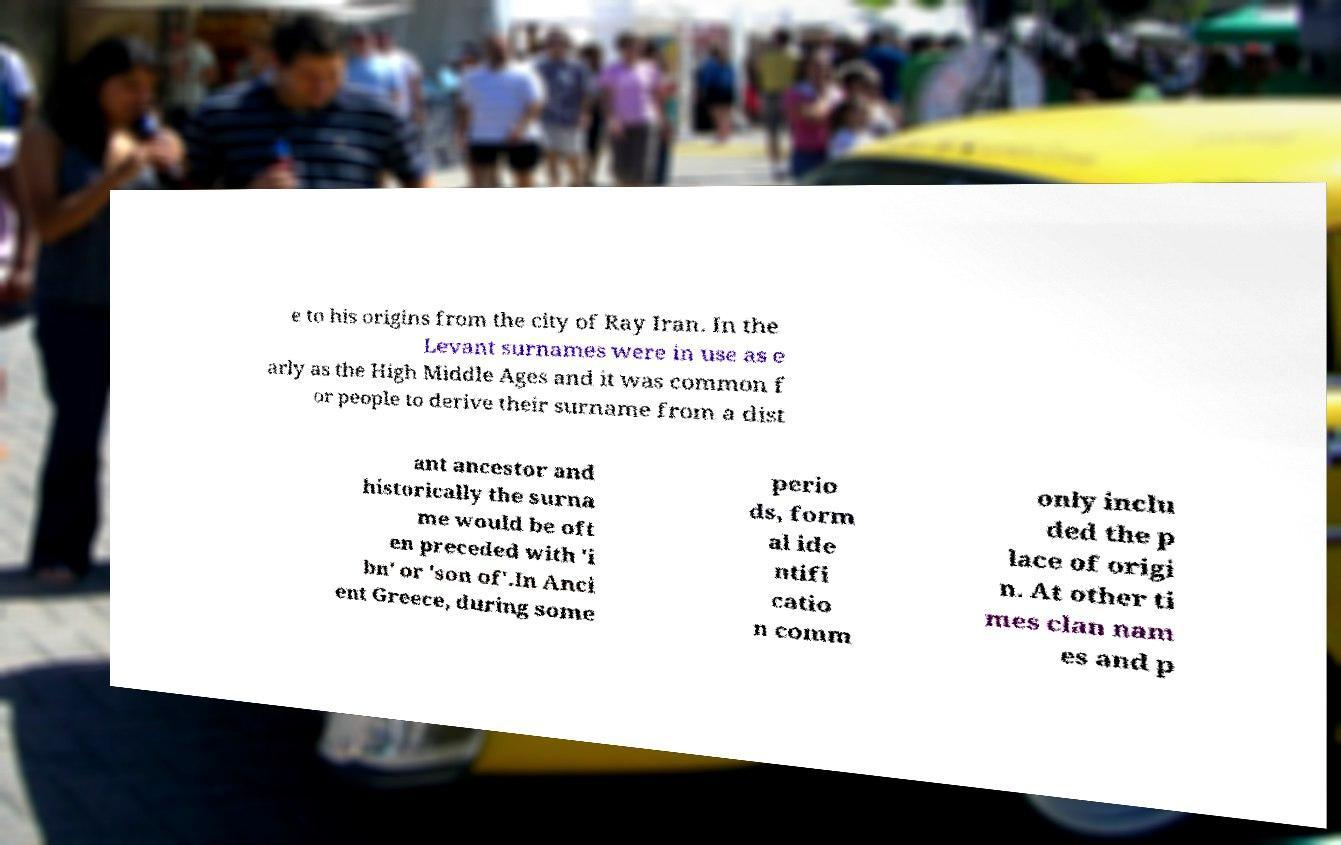Could you assist in decoding the text presented in this image and type it out clearly? e to his origins from the city of Ray Iran. In the Levant surnames were in use as e arly as the High Middle Ages and it was common f or people to derive their surname from a dist ant ancestor and historically the surna me would be oft en preceded with 'i bn' or 'son of'.In Anci ent Greece, during some perio ds, form al ide ntifi catio n comm only inclu ded the p lace of origi n. At other ti mes clan nam es and p 